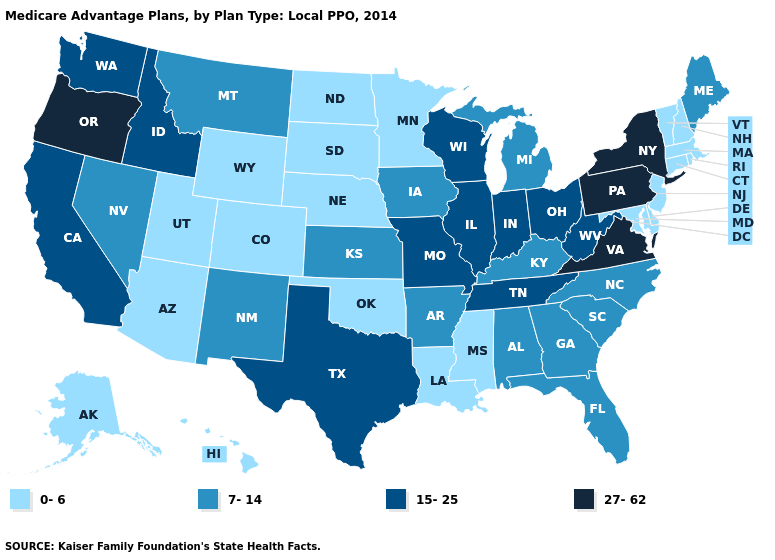Does the map have missing data?
Write a very short answer. No. Does the map have missing data?
Concise answer only. No. Which states have the lowest value in the MidWest?
Short answer required. Minnesota, North Dakota, Nebraska, South Dakota. What is the value of Oregon?
Answer briefly. 27-62. Does Vermont have the highest value in the USA?
Concise answer only. No. Which states have the lowest value in the South?
Keep it brief. Delaware, Louisiana, Maryland, Mississippi, Oklahoma. Does Arizona have a lower value than Oklahoma?
Short answer required. No. Is the legend a continuous bar?
Concise answer only. No. Which states have the highest value in the USA?
Be succinct. New York, Oregon, Pennsylvania, Virginia. Name the states that have a value in the range 27-62?
Short answer required. New York, Oregon, Pennsylvania, Virginia. What is the value of Florida?
Concise answer only. 7-14. Does Idaho have the lowest value in the West?
Short answer required. No. Is the legend a continuous bar?
Concise answer only. No. What is the value of Pennsylvania?
Short answer required. 27-62. Among the states that border Wyoming , which have the highest value?
Write a very short answer. Idaho. 